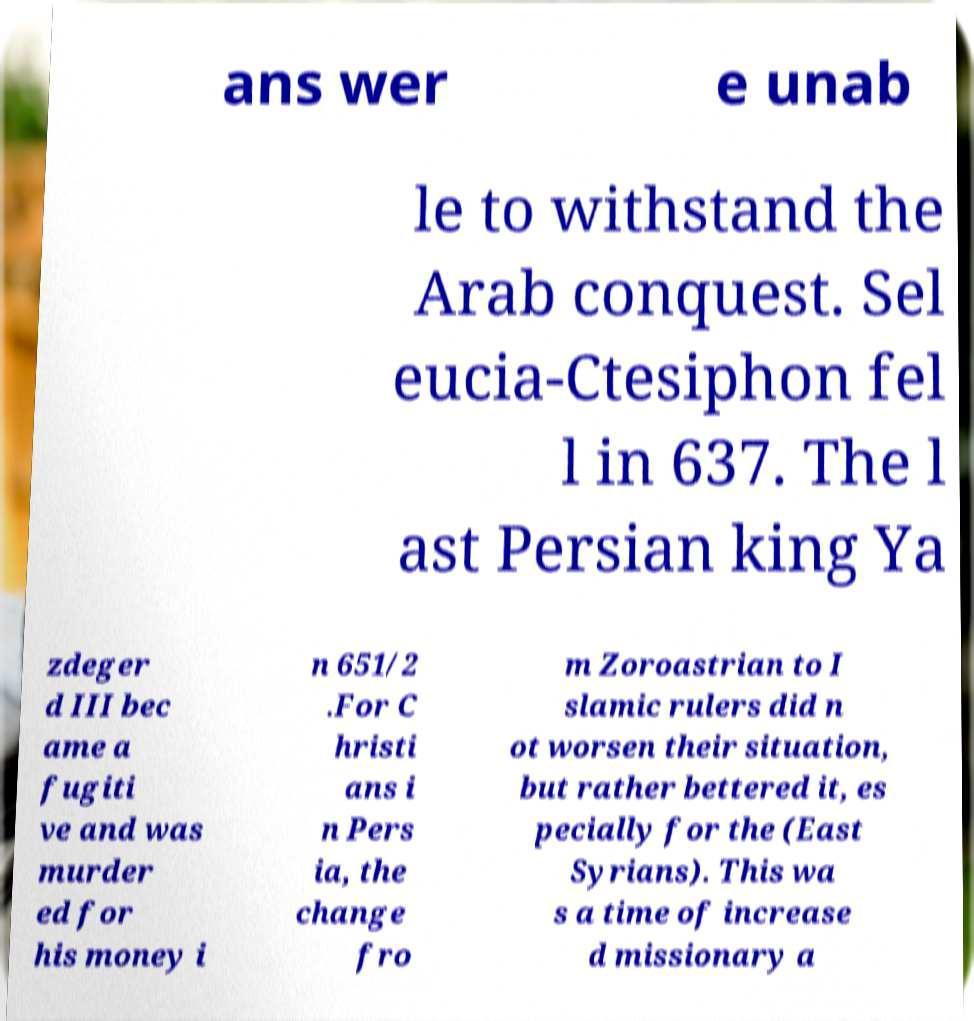For documentation purposes, I need the text within this image transcribed. Could you provide that? ans wer e unab le to withstand the Arab conquest. Sel eucia-Ctesiphon fel l in 637. The l ast Persian king Ya zdeger d III bec ame a fugiti ve and was murder ed for his money i n 651/2 .For C hristi ans i n Pers ia, the change fro m Zoroastrian to I slamic rulers did n ot worsen their situation, but rather bettered it, es pecially for the (East Syrians). This wa s a time of increase d missionary a 